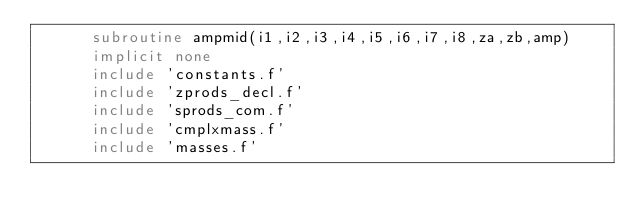Convert code to text. <code><loc_0><loc_0><loc_500><loc_500><_FORTRAN_>      subroutine ampmid(i1,i2,i3,i4,i5,i6,i7,i8,za,zb,amp)
      implicit none
      include 'constants.f'
      include 'zprods_decl.f'
      include 'sprods_com.f'
      include 'cmplxmass.f'
      include 'masses.f'</code> 